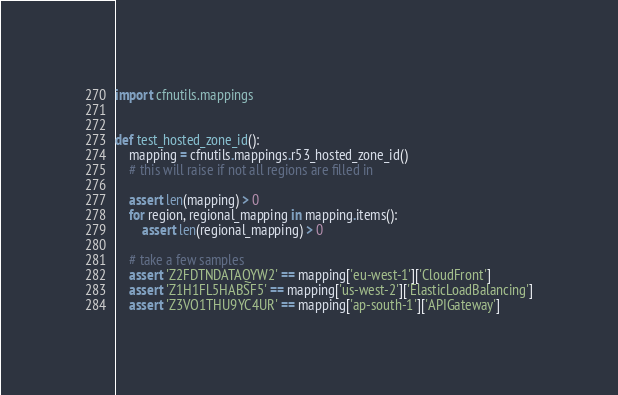Convert code to text. <code><loc_0><loc_0><loc_500><loc_500><_Python_>import cfnutils.mappings


def test_hosted_zone_id():
    mapping = cfnutils.mappings.r53_hosted_zone_id()
    # this will raise if not all regions are filled in

    assert len(mapping) > 0
    for region, regional_mapping in mapping.items():
        assert len(regional_mapping) > 0

    # take a few samples
    assert 'Z2FDTNDATAQYW2' == mapping['eu-west-1']['CloudFront']
    assert 'Z1H1FL5HABSF5' == mapping['us-west-2']['ElasticLoadBalancing']
    assert 'Z3VO1THU9YC4UR' == mapping['ap-south-1']['APIGateway']
</code> 